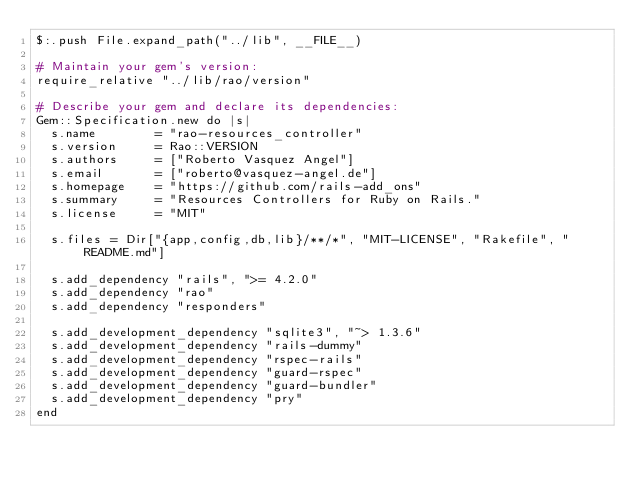<code> <loc_0><loc_0><loc_500><loc_500><_Ruby_>$:.push File.expand_path("../lib", __FILE__)

# Maintain your gem's version:
require_relative "../lib/rao/version"

# Describe your gem and declare its dependencies:
Gem::Specification.new do |s|
  s.name        = "rao-resources_controller"
  s.version     = Rao::VERSION
  s.authors     = ["Roberto Vasquez Angel"]
  s.email       = ["roberto@vasquez-angel.de"]
  s.homepage    = "https://github.com/rails-add_ons"
  s.summary     = "Resources Controllers for Ruby on Rails."
  s.license     = "MIT"

  s.files = Dir["{app,config,db,lib}/**/*", "MIT-LICENSE", "Rakefile", "README.md"]

  s.add_dependency "rails", ">= 4.2.0"
  s.add_dependency "rao"
  s.add_dependency "responders"

  s.add_development_dependency "sqlite3", "~> 1.3.6"
  s.add_development_dependency "rails-dummy"
  s.add_development_dependency "rspec-rails"
  s.add_development_dependency "guard-rspec"
  s.add_development_dependency "guard-bundler"
  s.add_development_dependency "pry"
end
</code> 